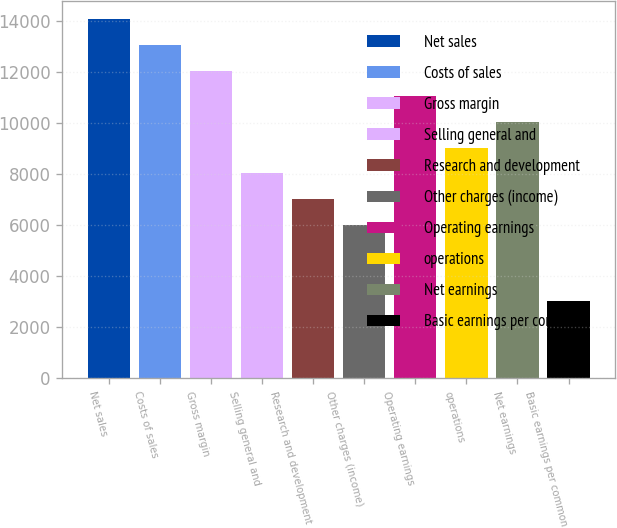Convert chart. <chart><loc_0><loc_0><loc_500><loc_500><bar_chart><fcel>Net sales<fcel>Costs of sales<fcel>Gross margin<fcel>Selling general and<fcel>Research and development<fcel>Other charges (income)<fcel>Operating earnings<fcel>operations<fcel>Net earnings<fcel>Basic earnings per common<nl><fcel>14054.6<fcel>13050.7<fcel>12046.8<fcel>8031.24<fcel>7027.34<fcel>6023.44<fcel>11042.9<fcel>9035.14<fcel>10039<fcel>3011.74<nl></chart> 